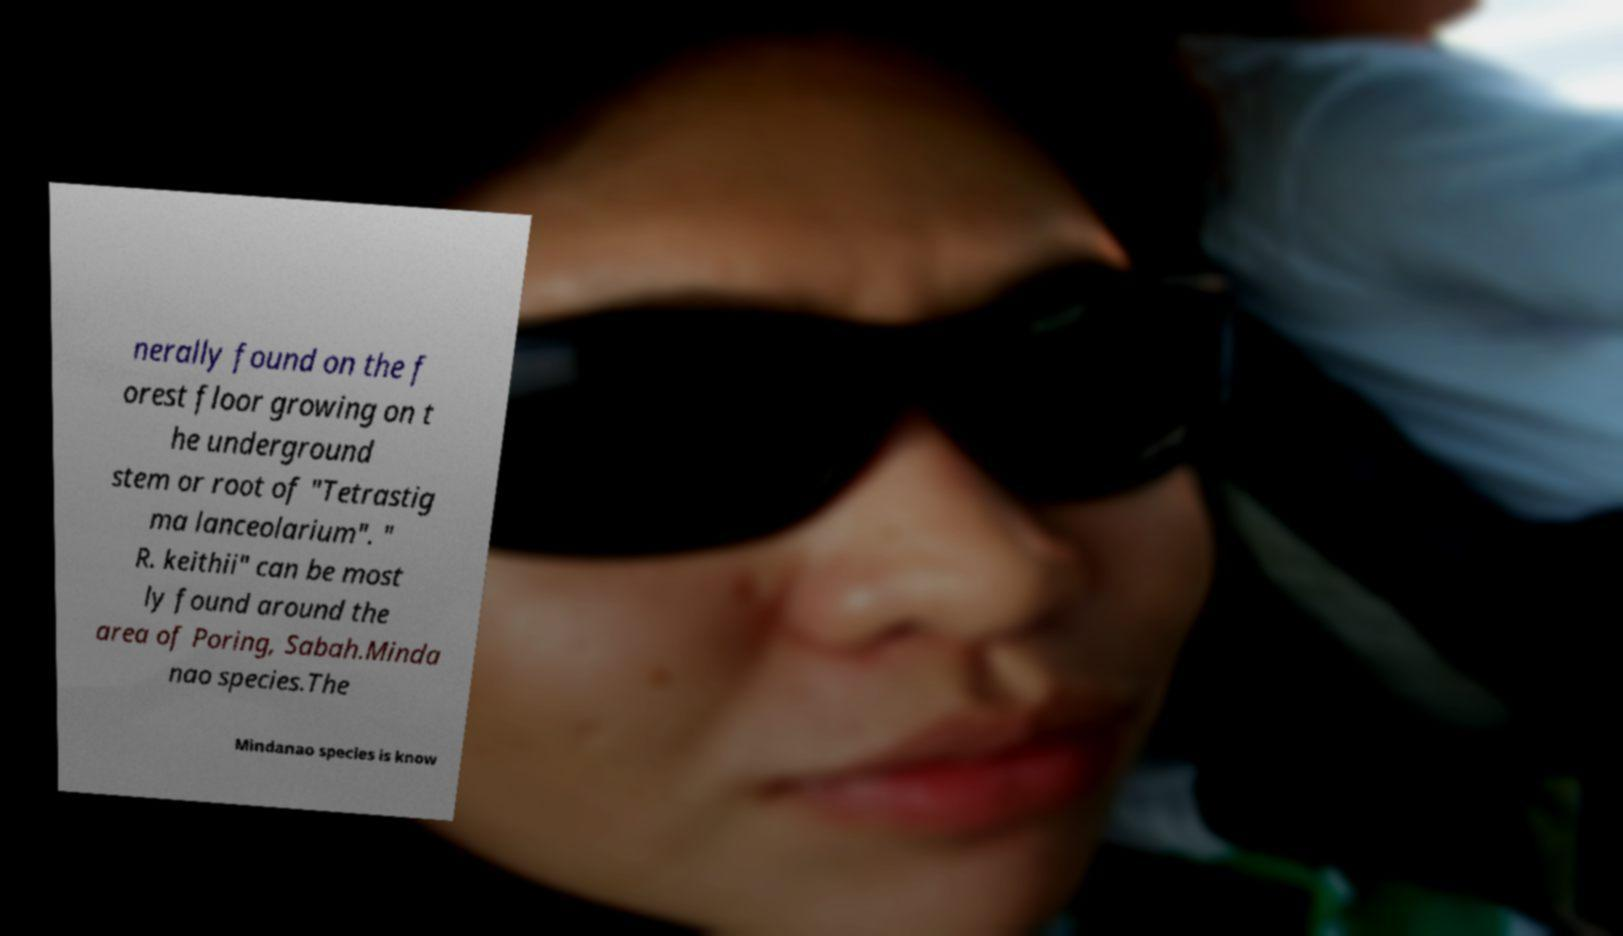Can you accurately transcribe the text from the provided image for me? nerally found on the f orest floor growing on t he underground stem or root of "Tetrastig ma lanceolarium". " R. keithii" can be most ly found around the area of Poring, Sabah.Minda nao species.The Mindanao species is know 